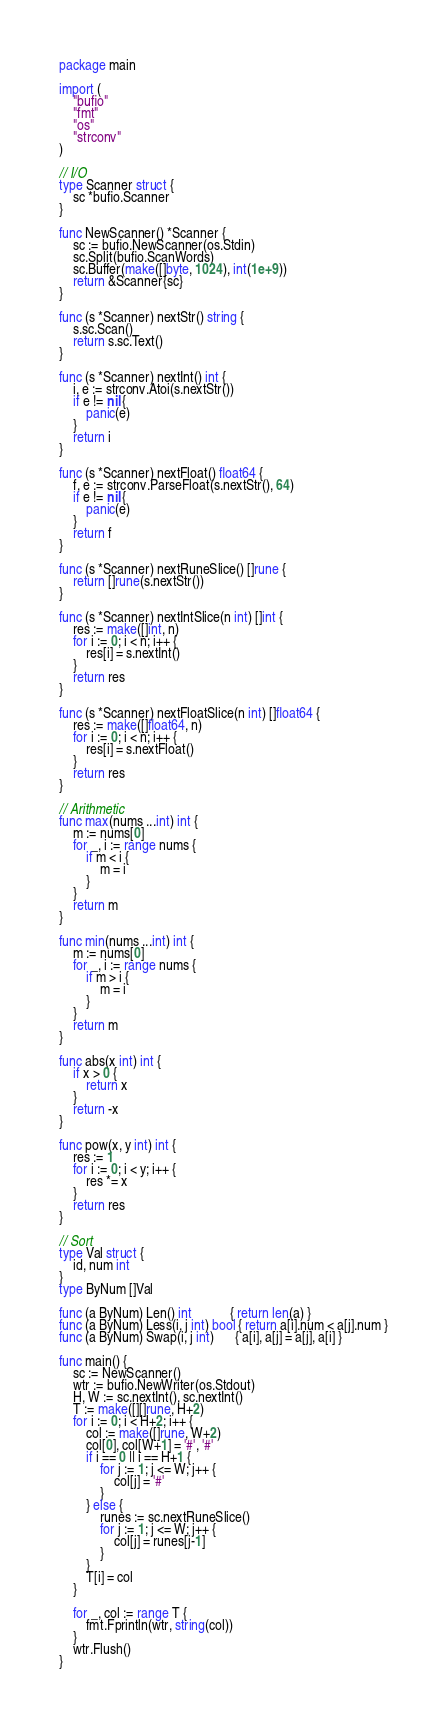Convert code to text. <code><loc_0><loc_0><loc_500><loc_500><_Go_>package main

import (
	"bufio"
	"fmt"
	"os"
	"strconv"
)

// I/O
type Scanner struct {
	sc *bufio.Scanner
}

func NewScanner() *Scanner {
	sc := bufio.NewScanner(os.Stdin)
	sc.Split(bufio.ScanWords)
	sc.Buffer(make([]byte, 1024), int(1e+9))
	return &Scanner{sc}
}

func (s *Scanner) nextStr() string {
	s.sc.Scan()
	return s.sc.Text()
}

func (s *Scanner) nextInt() int {
	i, e := strconv.Atoi(s.nextStr())
	if e != nil {
		panic(e)
	}
	return i
}

func (s *Scanner) nextFloat() float64 {
	f, e := strconv.ParseFloat(s.nextStr(), 64)
	if e != nil {
		panic(e)
	}
	return f
}

func (s *Scanner) nextRuneSlice() []rune {
	return []rune(s.nextStr())
}

func (s *Scanner) nextIntSlice(n int) []int {
	res := make([]int, n)
	for i := 0; i < n; i++ {
		res[i] = s.nextInt()
	}
	return res
}

func (s *Scanner) nextFloatSlice(n int) []float64 {
	res := make([]float64, n)
	for i := 0; i < n; i++ {
		res[i] = s.nextFloat()
	}
	return res
}

// Arithmetic
func max(nums ...int) int {
	m := nums[0]
	for _, i := range nums {
		if m < i {
			m = i
		}
	}
	return m
}

func min(nums ...int) int {
	m := nums[0]
	for _, i := range nums {
		if m > i {
			m = i
		}
	}
	return m
}

func abs(x int) int {
	if x > 0 {
		return x
	}
	return -x
}

func pow(x, y int) int {
	res := 1
	for i := 0; i < y; i++ {
		res *= x
	}
	return res
}

// Sort
type Val struct {
	id, num int
}
type ByNum []Val

func (a ByNum) Len() int           { return len(a) }
func (a ByNum) Less(i, j int) bool { return a[i].num < a[j].num }
func (a ByNum) Swap(i, j int)      { a[i], a[j] = a[j], a[i] }

func main() {
	sc := NewScanner()
	wtr := bufio.NewWriter(os.Stdout)
	H, W := sc.nextInt(), sc.nextInt()
	T := make([][]rune, H+2)
	for i := 0; i < H+2; i++ {
		col := make([]rune, W+2)
		col[0], col[W+1] = '#', '#'
		if i == 0 || i == H+1 {
			for j := 1; j <= W; j++ {
				col[j] = '#'
			}
		} else {
			runes := sc.nextRuneSlice()
			for j := 1; j <= W; j++ {
				col[j] = runes[j-1]
			}
		}
		T[i] = col
	}

	for _, col := range T {
		fmt.Fprintln(wtr, string(col))
	}
	wtr.Flush()
}
</code> 